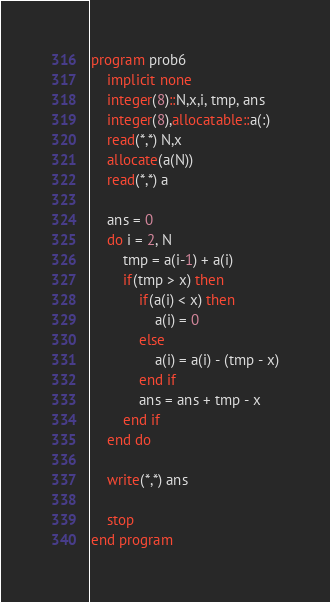<code> <loc_0><loc_0><loc_500><loc_500><_FORTRAN_>program prob6
    implicit none
    integer(8)::N,x,i, tmp, ans
    integer(8),allocatable::a(:)
    read(*,*) N,x
    allocate(a(N))
    read(*,*) a

    ans = 0
    do i = 2, N
        tmp = a(i-1) + a(i)
        if(tmp > x) then
            if(a(i) < x) then
                a(i) = 0
            else
                a(i) = a(i) - (tmp - x)
            end if
            ans = ans + tmp - x
        end if
    end do

    write(*,*) ans

    stop
end program</code> 